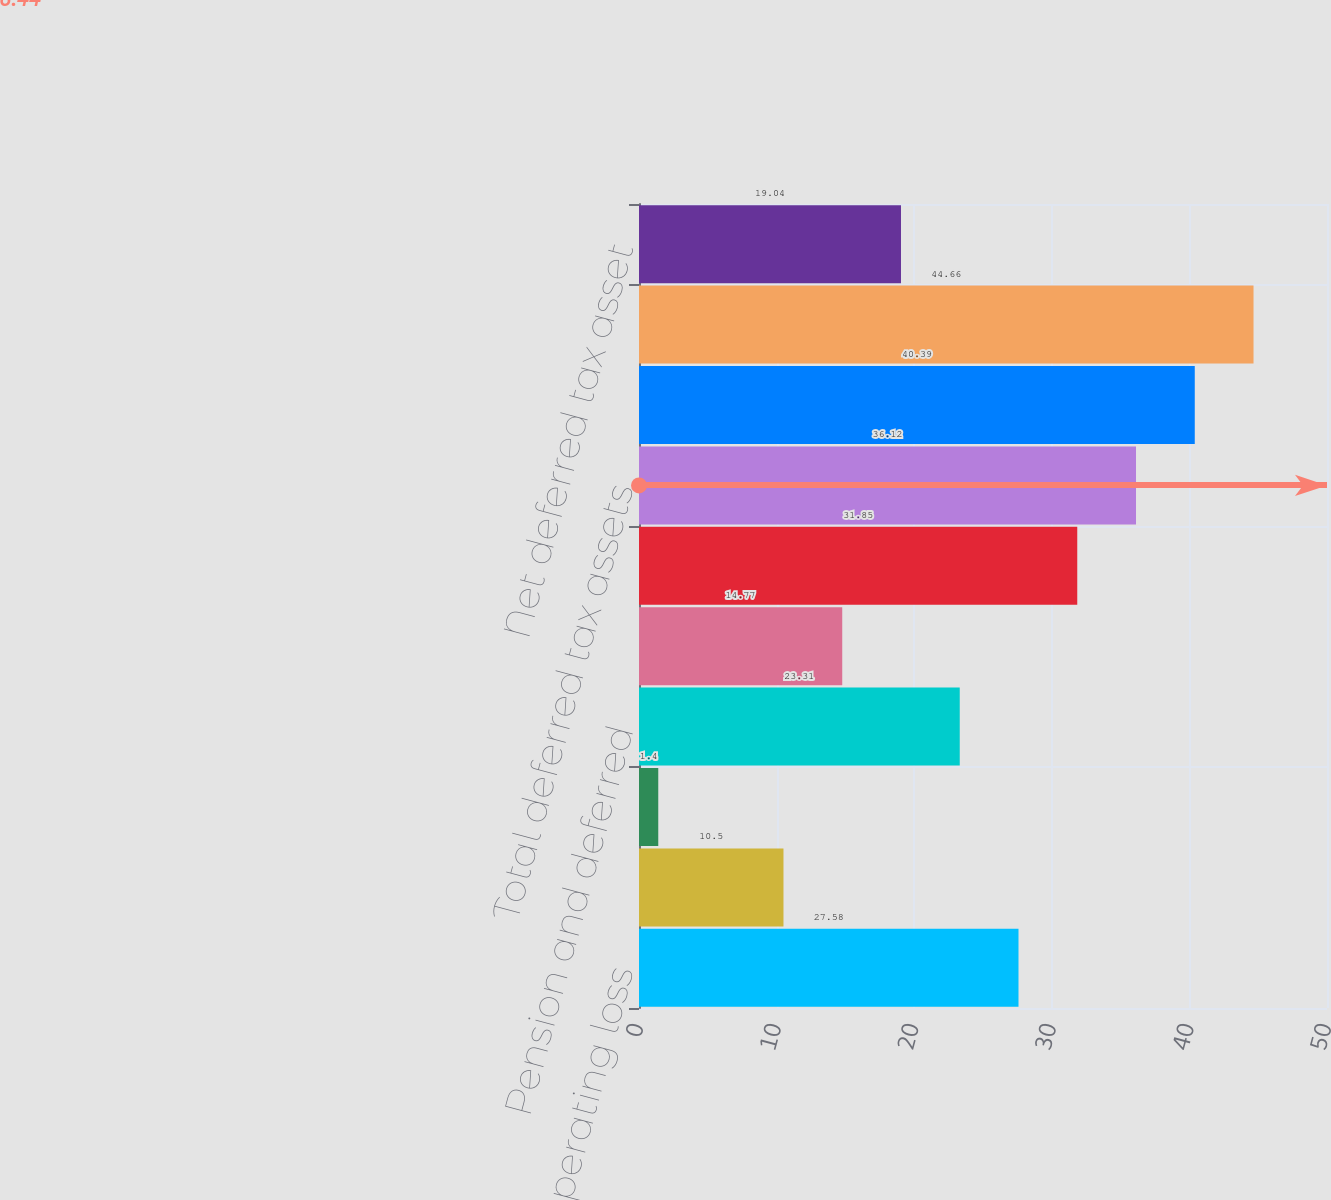<chart> <loc_0><loc_0><loc_500><loc_500><bar_chart><fcel>Net operating loss<fcel>Tax credit carryforwards<fcel>Capital loss carryforwards<fcel>Pension and deferred<fcel>Other<fcel>Valuation allowance<fcel>Total deferred tax assets<fcel>Accelerated depreciation<fcel>Total deferred tax liabilities<fcel>Net deferred tax asset<nl><fcel>27.58<fcel>10.5<fcel>1.4<fcel>23.31<fcel>14.77<fcel>31.85<fcel>36.12<fcel>40.39<fcel>44.66<fcel>19.04<nl></chart> 